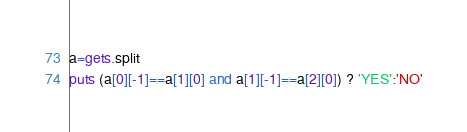Convert code to text. <code><loc_0><loc_0><loc_500><loc_500><_Ruby_>a=gets.split
puts (a[0][-1]==a[1][0] and a[1][-1]==a[2][0]) ? 'YES':'NO'</code> 